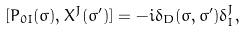Convert formula to latex. <formula><loc_0><loc_0><loc_500><loc_500>[ P _ { 0 I } ( \sigma ) , X ^ { J } ( \sigma ^ { \prime } ) ] = - i \delta _ { D } ( \sigma , \sigma ^ { \prime } ) \delta _ { I } ^ { J } ,</formula> 